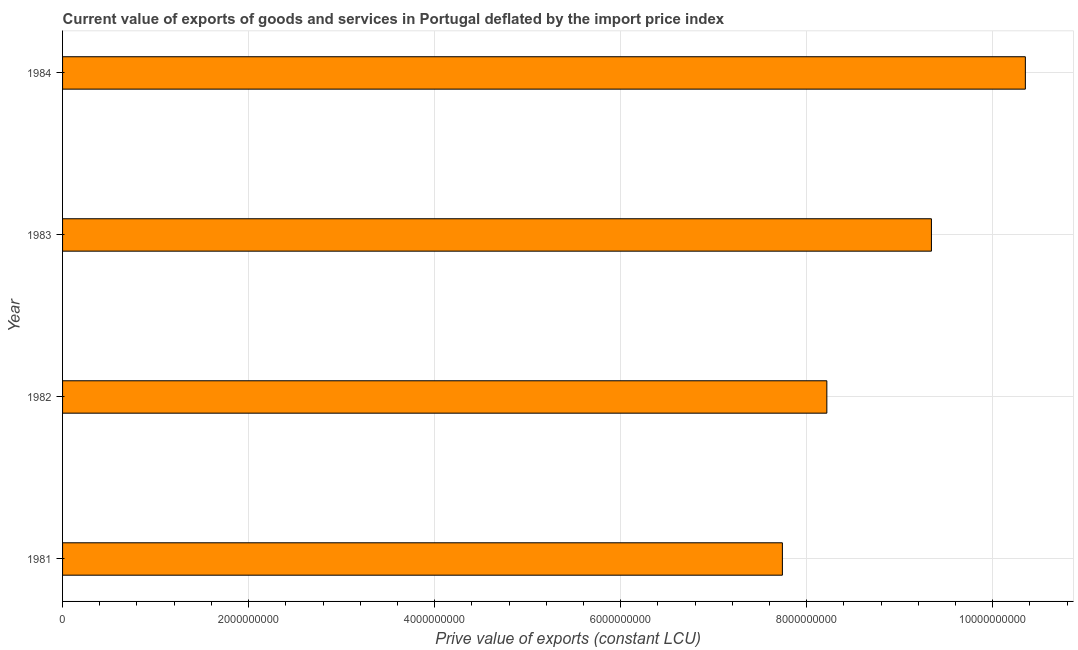What is the title of the graph?
Make the answer very short. Current value of exports of goods and services in Portugal deflated by the import price index. What is the label or title of the X-axis?
Offer a very short reply. Prive value of exports (constant LCU). What is the label or title of the Y-axis?
Offer a terse response. Year. What is the price value of exports in 1982?
Ensure brevity in your answer.  8.22e+09. Across all years, what is the maximum price value of exports?
Your response must be concise. 1.04e+1. Across all years, what is the minimum price value of exports?
Your answer should be very brief. 7.74e+09. In which year was the price value of exports minimum?
Give a very brief answer. 1981. What is the sum of the price value of exports?
Your answer should be very brief. 3.56e+1. What is the difference between the price value of exports in 1982 and 1984?
Offer a very short reply. -2.13e+09. What is the average price value of exports per year?
Make the answer very short. 8.91e+09. What is the median price value of exports?
Offer a very short reply. 8.78e+09. In how many years, is the price value of exports greater than 3600000000 LCU?
Ensure brevity in your answer.  4. What is the ratio of the price value of exports in 1981 to that in 1984?
Provide a succinct answer. 0.75. Is the price value of exports in 1982 less than that in 1983?
Keep it short and to the point. Yes. Is the difference between the price value of exports in 1981 and 1983 greater than the difference between any two years?
Your response must be concise. No. What is the difference between the highest and the second highest price value of exports?
Make the answer very short. 1.01e+09. What is the difference between the highest and the lowest price value of exports?
Make the answer very short. 2.61e+09. In how many years, is the price value of exports greater than the average price value of exports taken over all years?
Your answer should be very brief. 2. How many bars are there?
Your answer should be very brief. 4. Are all the bars in the graph horizontal?
Ensure brevity in your answer.  Yes. How many years are there in the graph?
Provide a short and direct response. 4. What is the difference between two consecutive major ticks on the X-axis?
Make the answer very short. 2.00e+09. Are the values on the major ticks of X-axis written in scientific E-notation?
Offer a very short reply. No. What is the Prive value of exports (constant LCU) of 1981?
Make the answer very short. 7.74e+09. What is the Prive value of exports (constant LCU) of 1982?
Offer a very short reply. 8.22e+09. What is the Prive value of exports (constant LCU) in 1983?
Your answer should be compact. 9.34e+09. What is the Prive value of exports (constant LCU) in 1984?
Your response must be concise. 1.04e+1. What is the difference between the Prive value of exports (constant LCU) in 1981 and 1982?
Your answer should be compact. -4.78e+08. What is the difference between the Prive value of exports (constant LCU) in 1981 and 1983?
Ensure brevity in your answer.  -1.60e+09. What is the difference between the Prive value of exports (constant LCU) in 1981 and 1984?
Your answer should be compact. -2.61e+09. What is the difference between the Prive value of exports (constant LCU) in 1982 and 1983?
Give a very brief answer. -1.12e+09. What is the difference between the Prive value of exports (constant LCU) in 1982 and 1984?
Provide a short and direct response. -2.13e+09. What is the difference between the Prive value of exports (constant LCU) in 1983 and 1984?
Keep it short and to the point. -1.01e+09. What is the ratio of the Prive value of exports (constant LCU) in 1981 to that in 1982?
Offer a very short reply. 0.94. What is the ratio of the Prive value of exports (constant LCU) in 1981 to that in 1983?
Ensure brevity in your answer.  0.83. What is the ratio of the Prive value of exports (constant LCU) in 1981 to that in 1984?
Offer a very short reply. 0.75. What is the ratio of the Prive value of exports (constant LCU) in 1982 to that in 1984?
Make the answer very short. 0.79. What is the ratio of the Prive value of exports (constant LCU) in 1983 to that in 1984?
Provide a succinct answer. 0.9. 